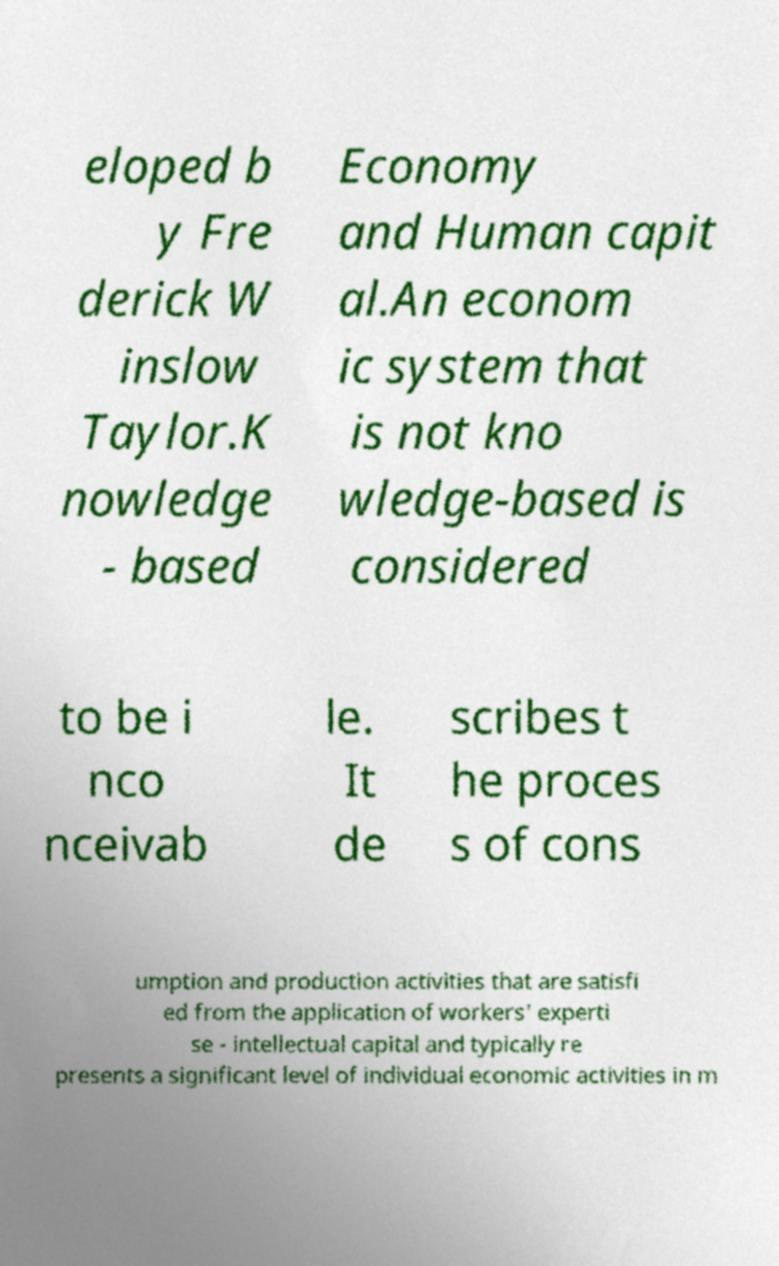Can you accurately transcribe the text from the provided image for me? eloped b y Fre derick W inslow Taylor.K nowledge - based Economy and Human capit al.An econom ic system that is not kno wledge-based is considered to be i nco nceivab le. It de scribes t he proces s of cons umption and production activities that are satisfi ed from the application of workers' experti se - intellectual capital and typically re presents a significant level of individual economic activities in m 